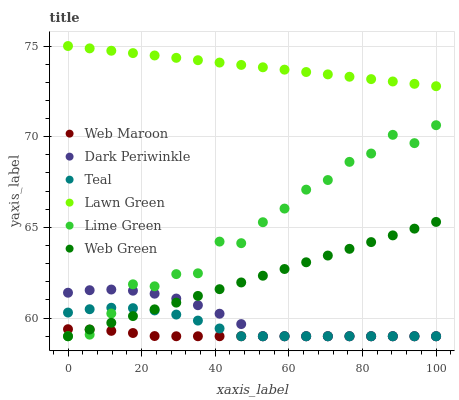Does Web Maroon have the minimum area under the curve?
Answer yes or no. Yes. Does Lawn Green have the maximum area under the curve?
Answer yes or no. Yes. Does Web Green have the minimum area under the curve?
Answer yes or no. No. Does Web Green have the maximum area under the curve?
Answer yes or no. No. Is Web Green the smoothest?
Answer yes or no. Yes. Is Lime Green the roughest?
Answer yes or no. Yes. Is Web Maroon the smoothest?
Answer yes or no. No. Is Web Maroon the roughest?
Answer yes or no. No. Does Web Maroon have the lowest value?
Answer yes or no. Yes. Does Lawn Green have the highest value?
Answer yes or no. Yes. Does Web Green have the highest value?
Answer yes or no. No. Is Lime Green less than Lawn Green?
Answer yes or no. Yes. Is Lawn Green greater than Web Green?
Answer yes or no. Yes. Does Web Maroon intersect Dark Periwinkle?
Answer yes or no. Yes. Is Web Maroon less than Dark Periwinkle?
Answer yes or no. No. Is Web Maroon greater than Dark Periwinkle?
Answer yes or no. No. Does Lime Green intersect Lawn Green?
Answer yes or no. No. 